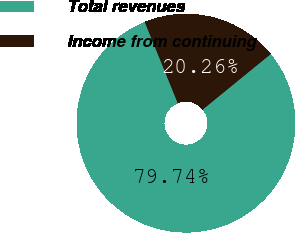Convert chart to OTSL. <chart><loc_0><loc_0><loc_500><loc_500><pie_chart><fcel>Total revenues<fcel>Income from continuing<nl><fcel>79.74%<fcel>20.26%<nl></chart> 